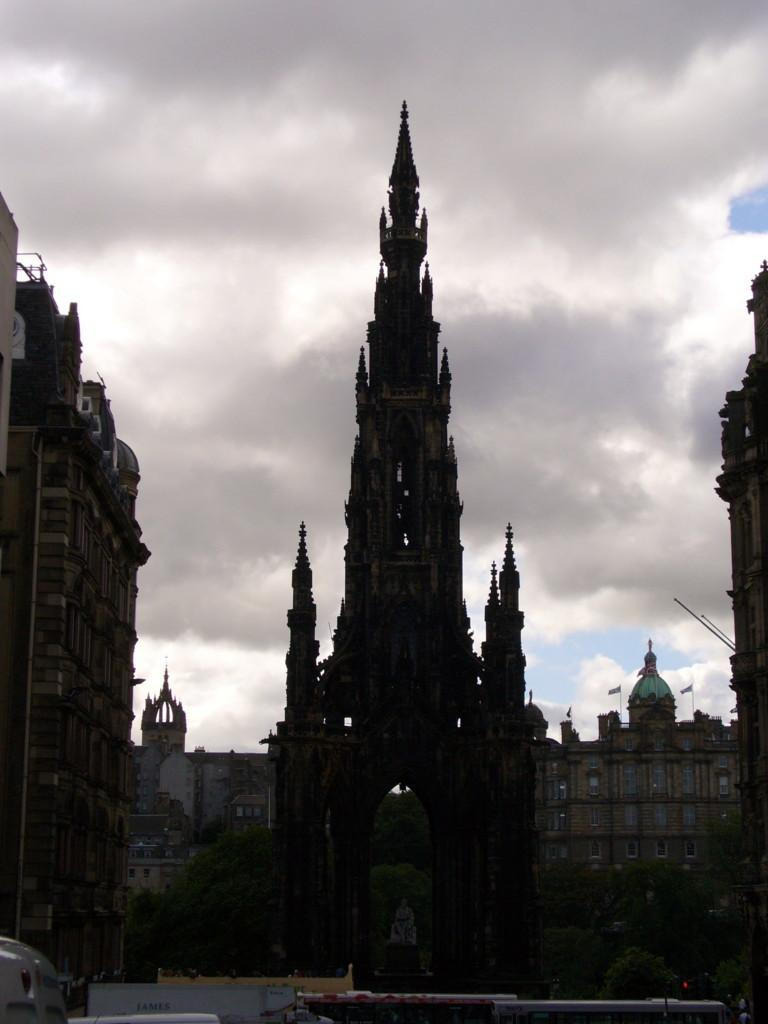What type of structures can be seen in the image? There are buildings in the image. What other natural elements are present in the image? There are trees in the image. Are there any man-made objects visible besides the buildings? Yes, there are vehicles in the image. What is visible in the background of the image? The sky is visible in the image, and there are clouds in the sky. What type of nail can be seen holding the clouds together in the image? There is no nail present in the image; the clouds are not held together by any visible object. Can you describe the beast that is roaming around the buildings in the image? There is no beast present in the image; the focus is on the buildings, trees, vehicles, and sky. 